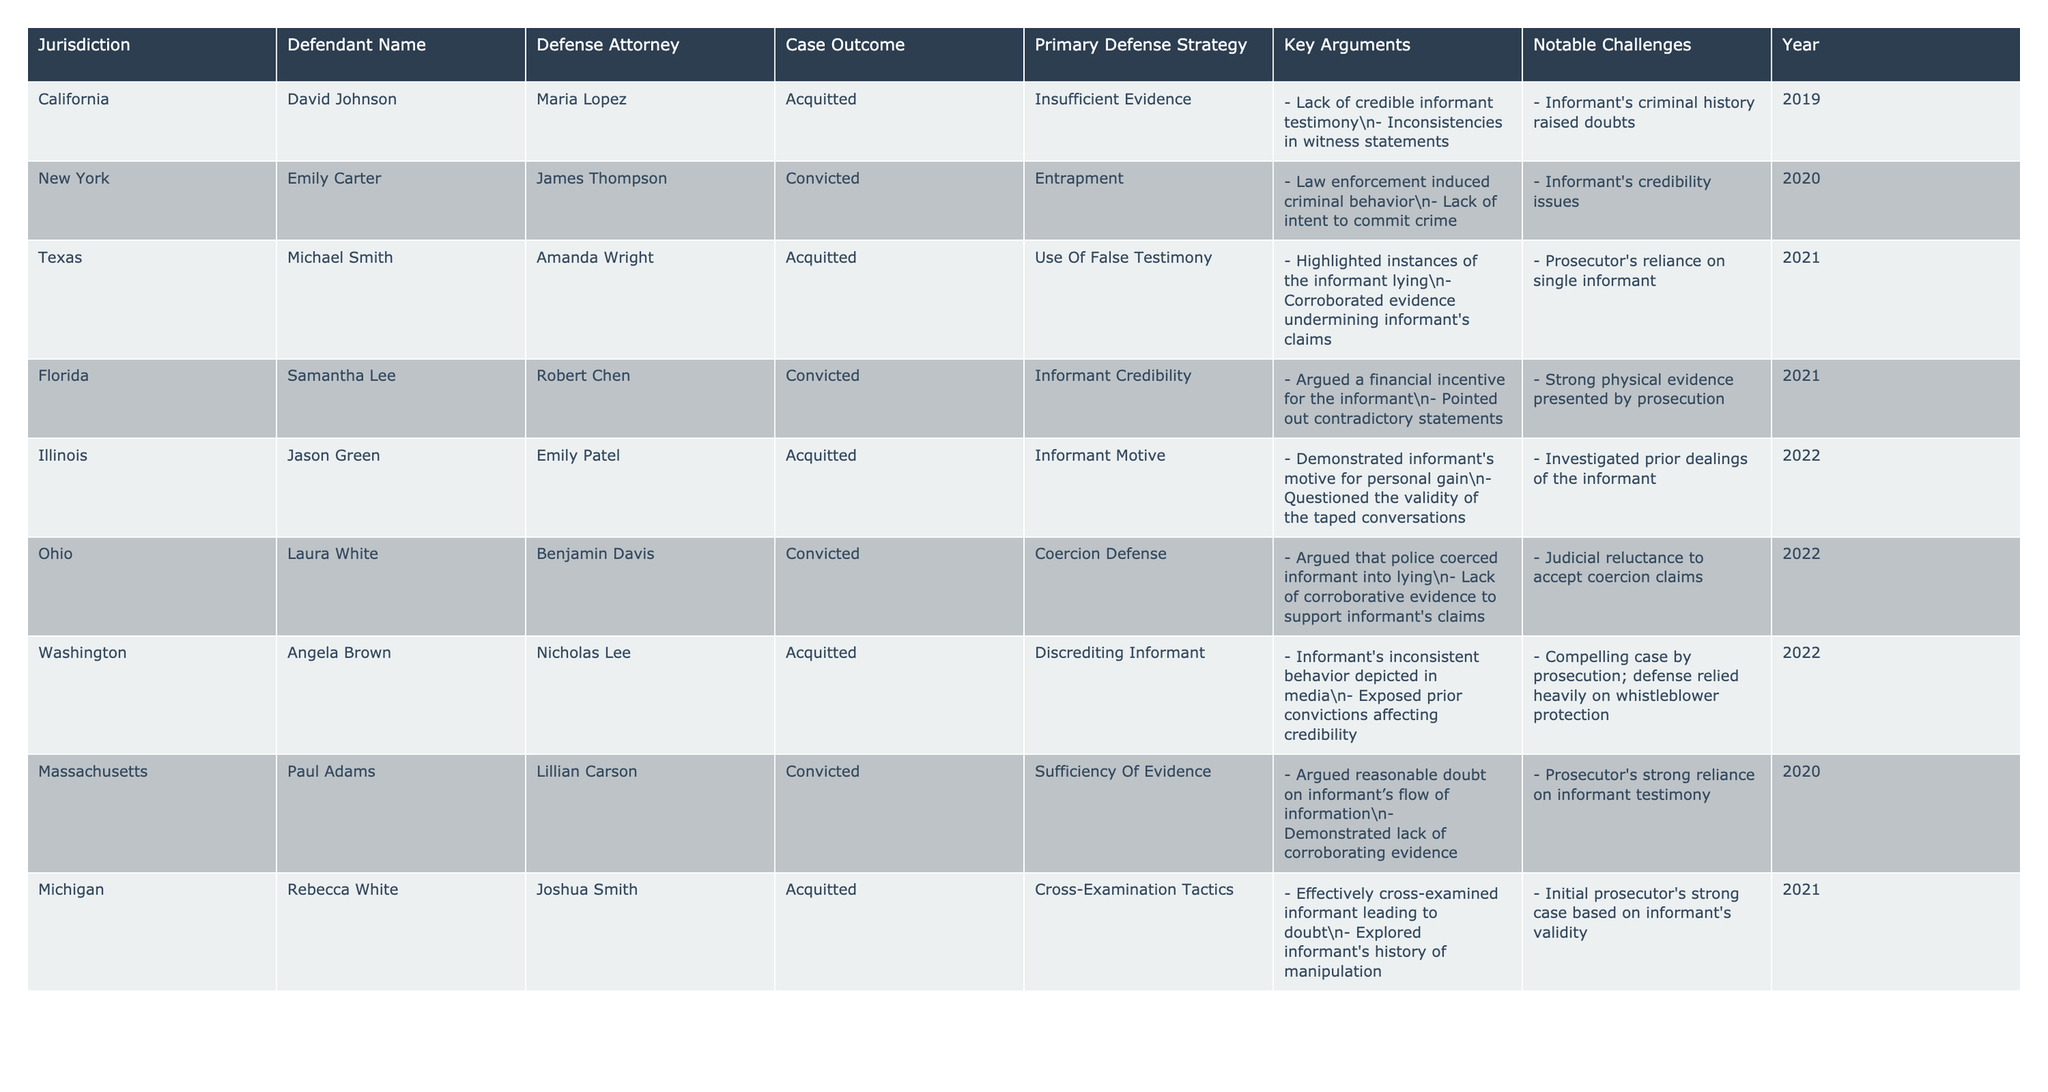What is the primary defense strategy used by David Johnson? Looking at the row corresponding to David Johnson, the primary defense strategy listed is "Insufficient Evidence."
Answer: Insufficient Evidence How many acquittals are indicated in the table? By examining each outcome in the table, there are a total of 5 acquittals: David Johnson, Michael Smith, Jason Green, Angela Brown, and Rebecca White.
Answer: 5 Which jurisdiction had the defendant with the highest number of convictions? By reviewing the rows, it is seen that both New York and Florida have 2 convictions, but there is no other jurisdiction with a higher number of convictions, so New York and Florida have the highest.
Answer: New York and Florida Did any defense strategies result in a conviction across multiple jurisdictions? Yes, "Entrapment" (New York), "Informant Credibility" (Florida), "Coercion Defense" (Ohio), and "Sufficiency of Evidence" (Massachusetts) resulted in convictions across different jurisdictions.
Answer: Yes What was the notable challenge faced by the defense in the case of Laura White in Ohio? The table indicates that the notable challenge was the "Judicial reluctance to accept coercion claims."
Answer: Judicial reluctance to accept coercion claims Which defendant argued about the motive behind the informant's claims? Referring to Jason Green's row, it shows that he argued about the informant's motive for personal gain as the primary defense strategy.
Answer: Jason Green Calculate the average year of acquittals from the available data. The years of acquittals are 2019, 2021, 2022, 2022, and 2021. The sum is (2019 + 2021 + 2022 + 2022 + 2021) = 10005 and the average is 10005 / 5 = 2001.
Answer: 2021 What common argument was noted regarding informants' credibility? Consistently, arguments pointed to the informants' prior convictions, financial incentives, and inconsistencies in statements which undermine their credibility.
Answer: Informants' credibility concerns Was the defense successful in utilizing cross-examination tactics in the case of Rebecca White? Yes, the table states that Rebecca White was acquitted, and the successful tactic involved effectively cross-examining the informant.
Answer: Yes In which year did the highest number of acquittals occur? The highest number of acquittals (3) occurred in 2022, as seen from Angela Brown, Jason Green, and Rebecca White's cases.
Answer: 2022 